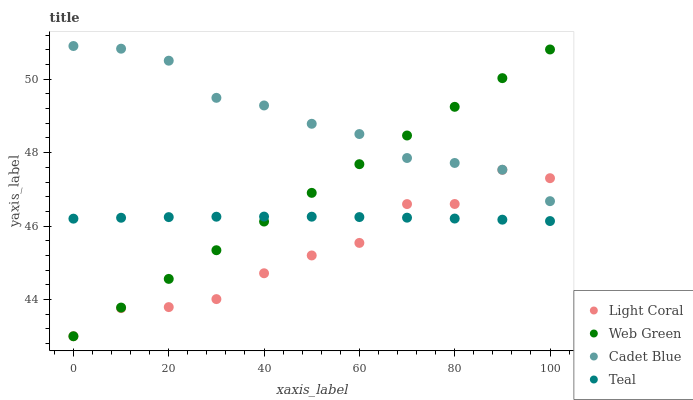Does Light Coral have the minimum area under the curve?
Answer yes or no. Yes. Does Cadet Blue have the maximum area under the curve?
Answer yes or no. Yes. Does Teal have the minimum area under the curve?
Answer yes or no. No. Does Teal have the maximum area under the curve?
Answer yes or no. No. Is Web Green the smoothest?
Answer yes or no. Yes. Is Light Coral the roughest?
Answer yes or no. Yes. Is Cadet Blue the smoothest?
Answer yes or no. No. Is Cadet Blue the roughest?
Answer yes or no. No. Does Light Coral have the lowest value?
Answer yes or no. Yes. Does Teal have the lowest value?
Answer yes or no. No. Does Cadet Blue have the highest value?
Answer yes or no. Yes. Does Teal have the highest value?
Answer yes or no. No. Is Teal less than Cadet Blue?
Answer yes or no. Yes. Is Cadet Blue greater than Teal?
Answer yes or no. Yes. Does Web Green intersect Cadet Blue?
Answer yes or no. Yes. Is Web Green less than Cadet Blue?
Answer yes or no. No. Is Web Green greater than Cadet Blue?
Answer yes or no. No. Does Teal intersect Cadet Blue?
Answer yes or no. No. 